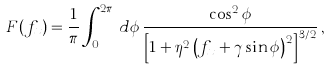Convert formula to latex. <formula><loc_0><loc_0><loc_500><loc_500>F ( f _ { x } ) = \frac { 1 } { \pi } \int _ { 0 } ^ { 2 \pi } \, d \phi \, \frac { \cos ^ { 2 } \phi } { \left [ 1 + \eta ^ { 2 } \left ( f _ { x } + \gamma \sin \phi \right ) ^ { 2 } \right ] ^ { 3 / 2 } } \, ,</formula> 